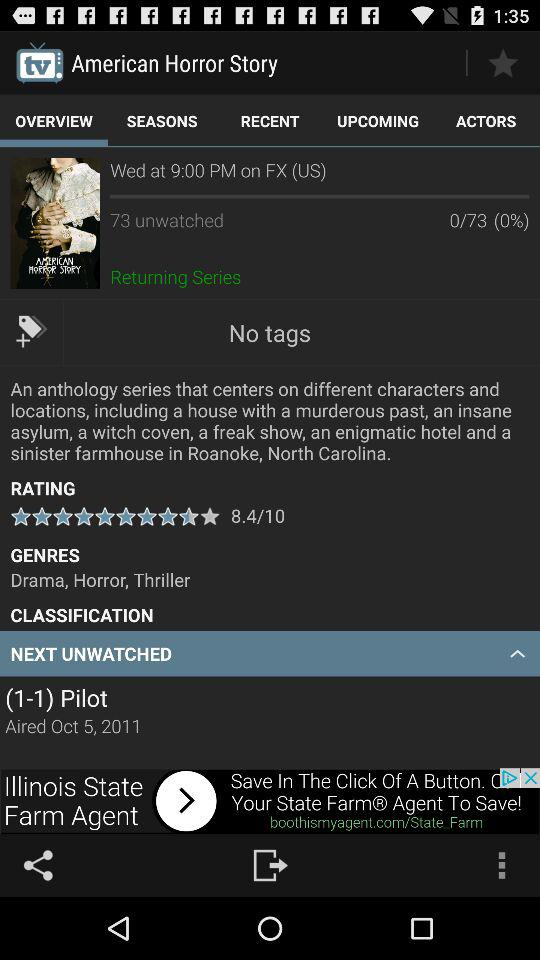How many episodes has American Horror Story aired?
Answer the question using a single word or phrase. 73 